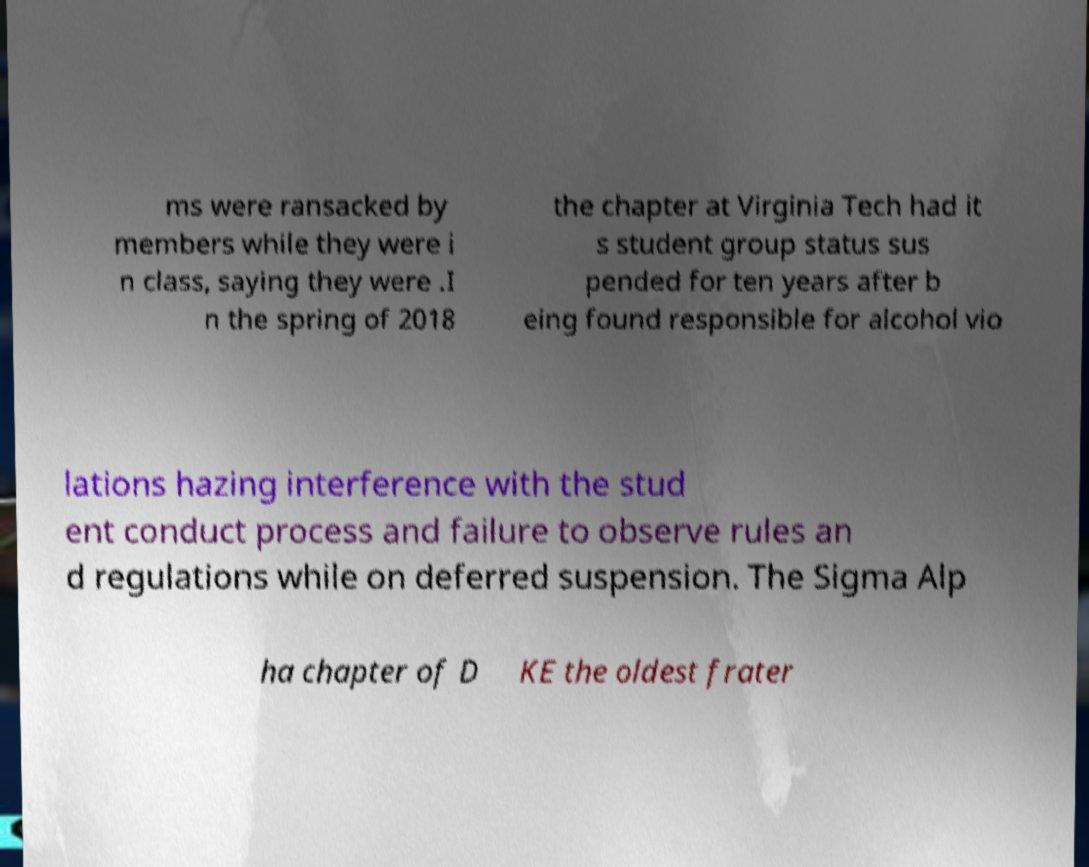What messages or text are displayed in this image? I need them in a readable, typed format. ms were ransacked by members while they were i n class, saying they were .I n the spring of 2018 the chapter at Virginia Tech had it s student group status sus pended for ten years after b eing found responsible for alcohol vio lations hazing interference with the stud ent conduct process and failure to observe rules an d regulations while on deferred suspension. The Sigma Alp ha chapter of D KE the oldest frater 